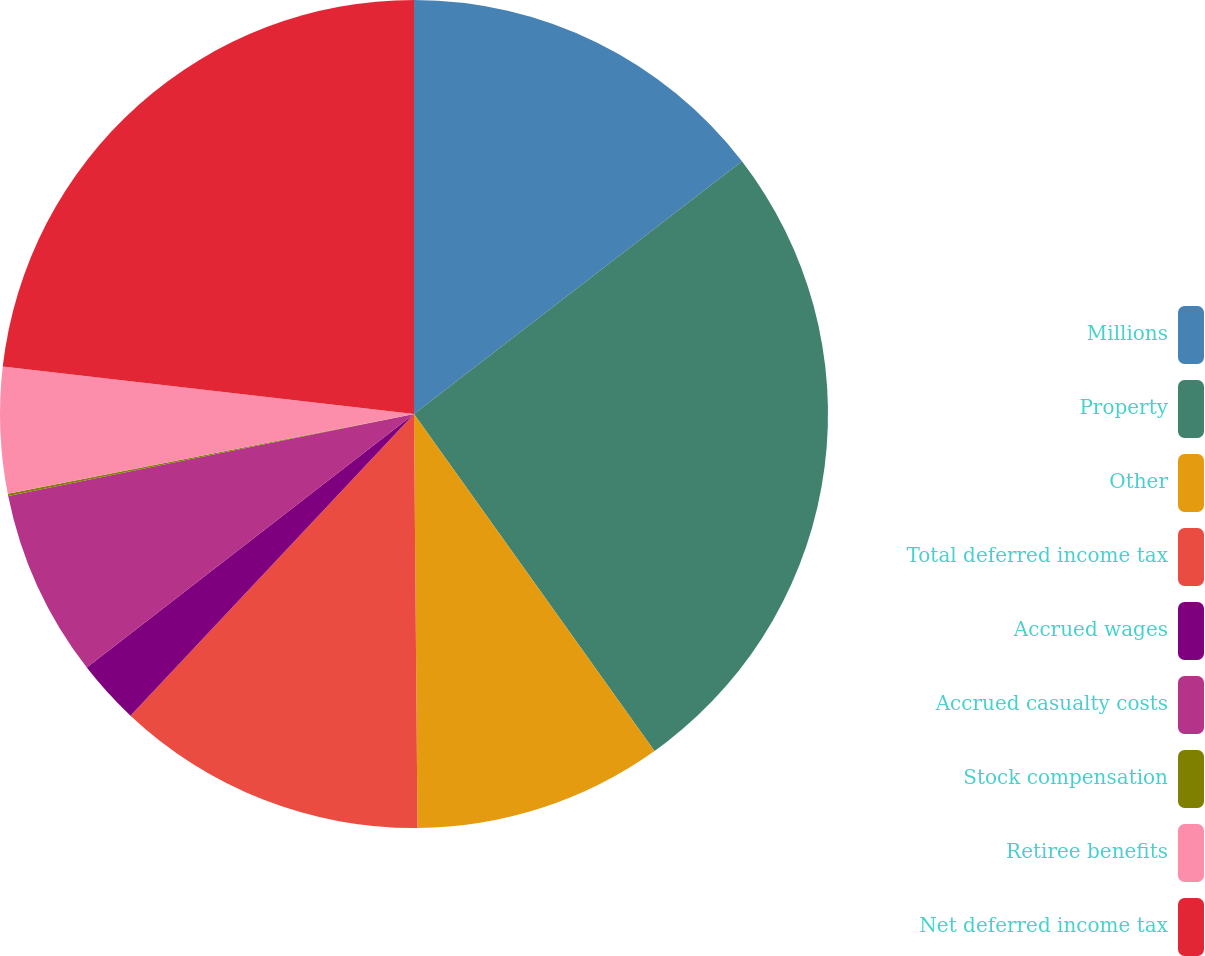<chart> <loc_0><loc_0><loc_500><loc_500><pie_chart><fcel>Millions<fcel>Property<fcel>Other<fcel>Total deferred income tax<fcel>Accrued wages<fcel>Accrued casualty costs<fcel>Stock compensation<fcel>Retiree benefits<fcel>Net deferred income tax<nl><fcel>14.55%<fcel>25.58%<fcel>9.73%<fcel>12.14%<fcel>2.5%<fcel>7.32%<fcel>0.09%<fcel>4.91%<fcel>23.17%<nl></chart> 